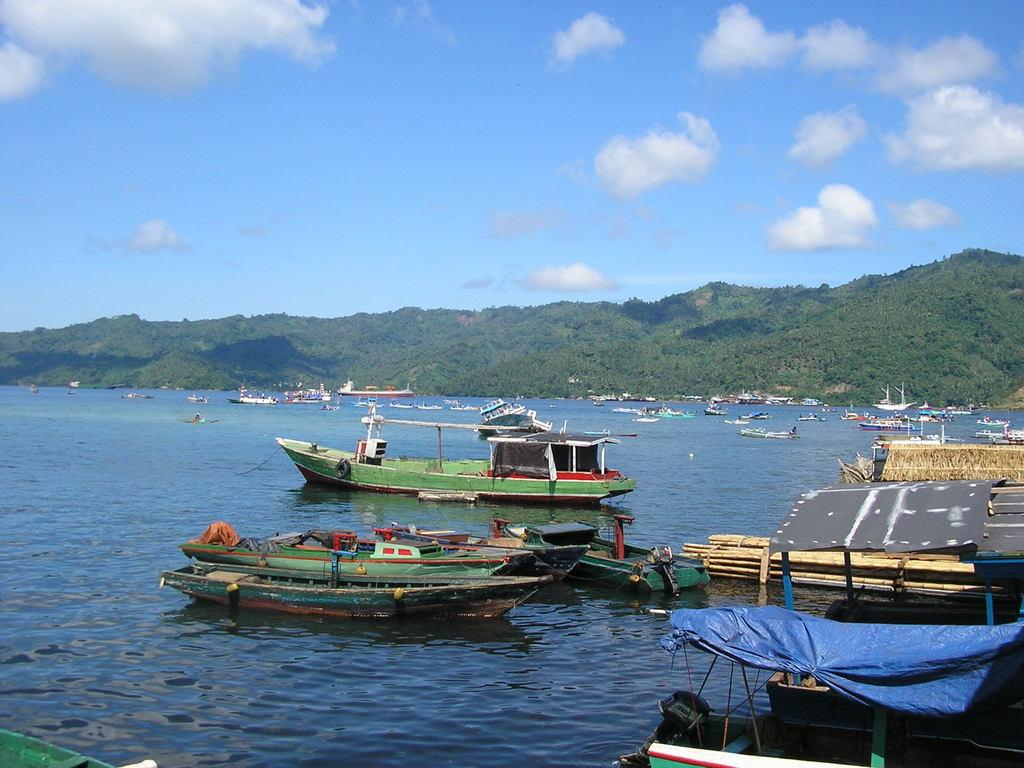What is present on the water in the image? There are boats on the water in the image. What can be seen in the background of the image? There are hills and the sky visible in the background of the image. What type of creature can be seen helping the fireman in the image? There is no creature or fireman present in the image; it features boats on the water and hills in the background. 